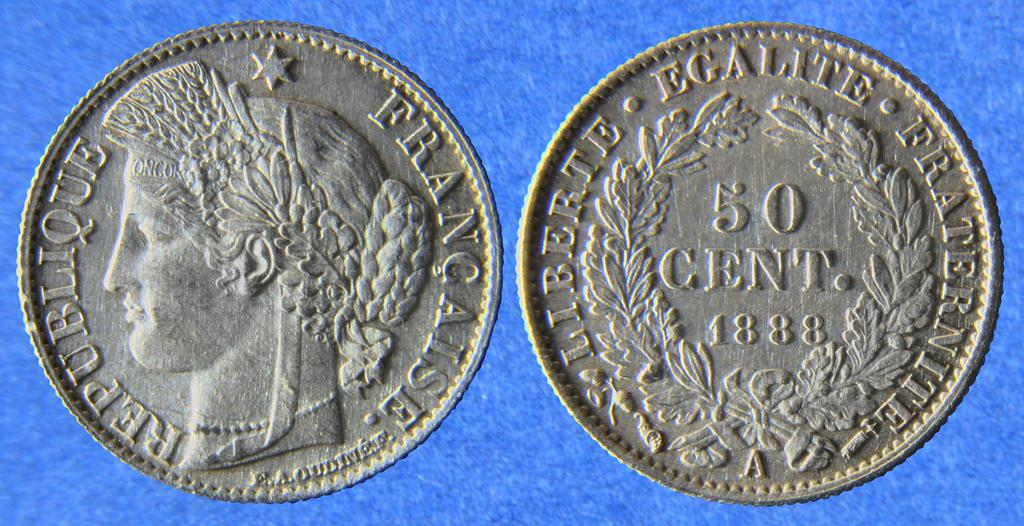<image>
Summarize the visual content of the image. Silver coin that says "50 cent" and the year 1888. 